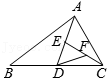Can you explain how the area value of 4 cm² might impact the calculations involving triangle ABC and its divisions? With the area of the triangle known as 4 cm², any subdivision of the triangle through points D, E, and F would allow the calculation of smaller areas within the triangle. This information is pivotal in validating geometric properties or proving specific proportionality among the segments, helpful in numerous practical and theoretical applications in geometry. 